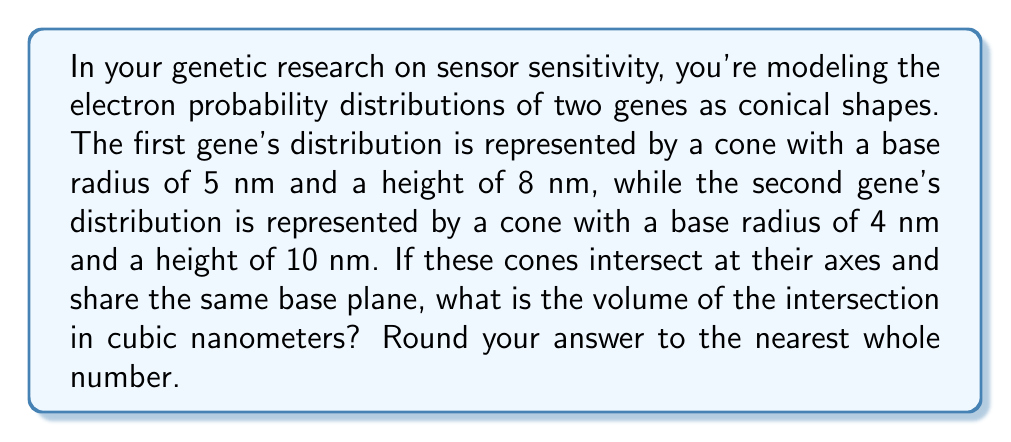Can you answer this question? To solve this problem, we need to follow these steps:

1) First, we need to determine which cone is "inside" the other at the intersection. We can do this by comparing their angles.

2) The angle of a cone can be calculated using the formula:
   $$\theta = \arctan(\frac{r}{h})$$
   where $r$ is the radius and $h$ is the height.

3) For the first cone:
   $$\theta_1 = \arctan(\frac{5}{8}) \approx 32.0°$$

4) For the second cone:
   $$\theta_2 = \arctan(\frac{4}{10}) \approx 21.8°$$

5) Since $\theta_1 > \theta_2$, the second cone will be inside the first at the intersection.

6) The height of the intersection will be the height of the smaller cone, which is 10 nm.

7) To find the radius of the base of the intersection, we use the ratio of the second cone:
   $$\frac{4}{10} = \frac{r}{10}$$
   $$r = 4 \text{ nm}$$

8) Now we can calculate the volume of the intersection using the formula for the volume of a cone:
   $$V = \frac{1}{3}\pi r^2 h$$

9) Plugging in our values:
   $$V = \frac{1}{3}\pi (4\text{ nm})^2 (10\text{ nm})$$
   $$V = \frac{160}{3}\pi \text{ nm}^3$$
   $$V \approx 167.55 \text{ nm}^3$$

10) Rounding to the nearest whole number:
    $$V \approx 168 \text{ nm}^3$$
Answer: 168 nm³ 